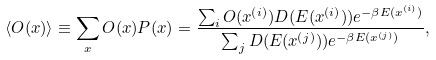Convert formula to latex. <formula><loc_0><loc_0><loc_500><loc_500>\langle O ( x ) \rangle \equiv \sum _ { x } O ( x ) P ( x ) = \frac { \sum _ { i } O ( x ^ { ( i ) } ) D ( E ( x ^ { ( i ) } ) ) e ^ { - \beta E ( x ^ { ( i ) } ) } } { \sum _ { j } D ( E ( x ^ { ( j ) } ) ) e ^ { - \beta E ( x ^ { ( j ) } ) } } ,</formula> 